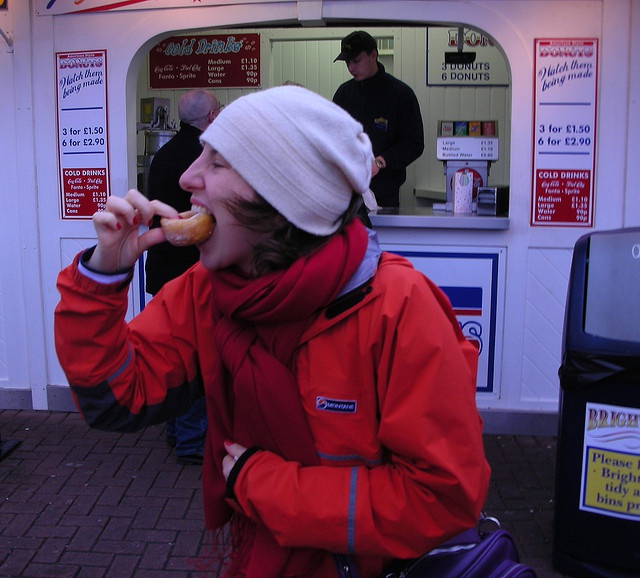Describe the objects in this image and their specific colors. I can see people in orange, maroon, brown, black, and violet tones, people in orange, black, gray, lavender, and darkgray tones, handbag in orange, black, navy, blue, and darkblue tones, people in orange, black, purple, and navy tones, and donut in orange, brown, maroon, darkgray, and purple tones in this image. 